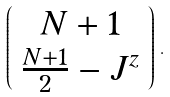<formula> <loc_0><loc_0><loc_500><loc_500>\left ( \begin{array} { c } N + 1 \\ \frac { N + 1 } { 2 } - J ^ { z } \end{array} \right ) \, .</formula> 